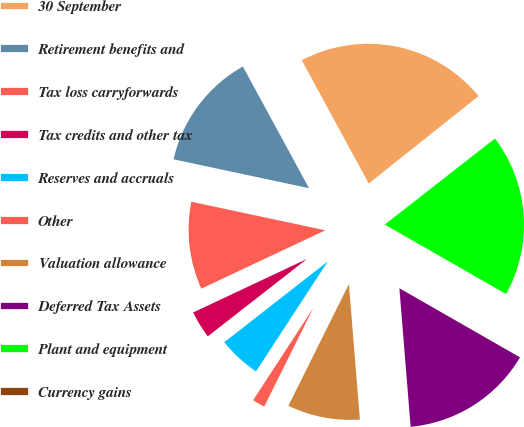Convert chart to OTSL. <chart><loc_0><loc_0><loc_500><loc_500><pie_chart><fcel>30 September<fcel>Retirement benefits and<fcel>Tax loss carryforwards<fcel>Tax credits and other tax<fcel>Reserves and accruals<fcel>Other<fcel>Valuation allowance<fcel>Deferred Tax Assets<fcel>Plant and equipment<fcel>Currency gains<nl><fcel>22.22%<fcel>13.73%<fcel>10.34%<fcel>3.55%<fcel>5.25%<fcel>1.85%<fcel>8.64%<fcel>15.43%<fcel>18.83%<fcel>0.15%<nl></chart> 